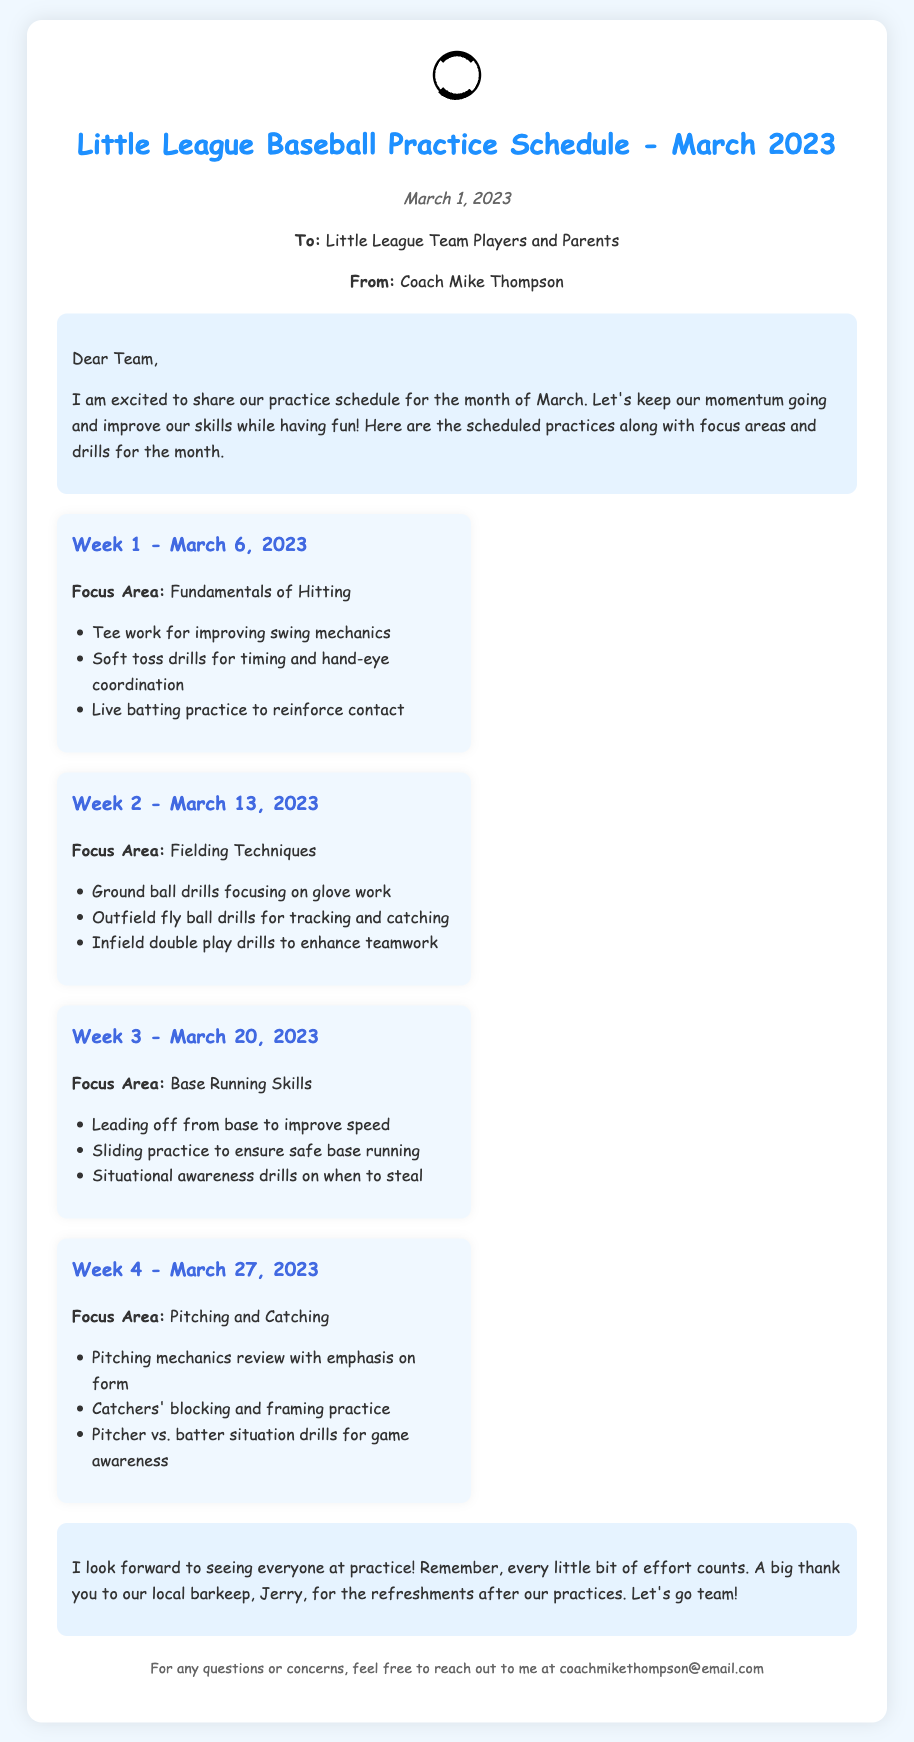what is the focus area for Week 1? The focus area for Week 1, March 6, 2023, is mentioned in the section as "Fundamentals of Hitting."
Answer: Fundamentals of Hitting what is the date of the last practice in March? The last practice is scheduled in the document for March 27, 2023.
Answer: March 27, 2023 who is the author of the memo? The author is identified in the document as "Coach Mike Thompson."
Answer: Coach Mike Thompson what drill focuses on safe base running? The sliding practice is designed to ensure safe base running.
Answer: Sliding practice how many weeks are covered in the practice schedule? The document presents a schedule that spans four weeks for March 2023.
Answer: Four weeks which local barkeep is mentioned in the conclusion? The document mentions "Jerry" as the local barkeep supporting the team.
Answer: Jerry what is the main focus area for Week 3? Week 3 focuses on "Base Running Skills."
Answer: Base Running Skills how are the practices structured in the memo? The practices are structured into weeks, each detailing a focus area and specific drills.
Answer: Into weeks with focus areas and drills what is given at the end of the practices? The memo thanks Jerry for the "refreshments after our practices."
Answer: Refreshments 